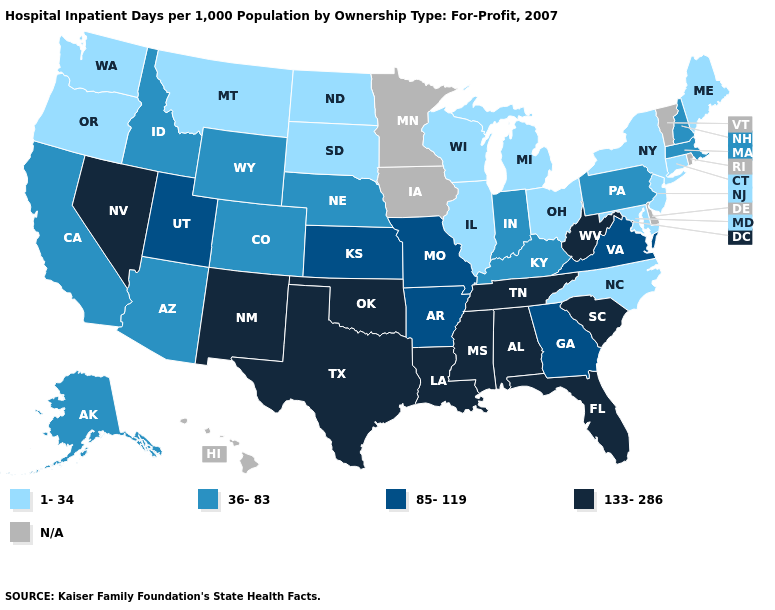Name the states that have a value in the range 36-83?
Answer briefly. Alaska, Arizona, California, Colorado, Idaho, Indiana, Kentucky, Massachusetts, Nebraska, New Hampshire, Pennsylvania, Wyoming. Which states have the highest value in the USA?
Concise answer only. Alabama, Florida, Louisiana, Mississippi, Nevada, New Mexico, Oklahoma, South Carolina, Tennessee, Texas, West Virginia. Does North Carolina have the lowest value in the South?
Be succinct. Yes. Name the states that have a value in the range 133-286?
Give a very brief answer. Alabama, Florida, Louisiana, Mississippi, Nevada, New Mexico, Oklahoma, South Carolina, Tennessee, Texas, West Virginia. What is the value of Oklahoma?
Short answer required. 133-286. What is the value of Kansas?
Keep it brief. 85-119. What is the value of New York?
Keep it brief. 1-34. Does Indiana have the highest value in the USA?
Concise answer only. No. What is the value of Alaska?
Keep it brief. 36-83. Does New York have the lowest value in the Northeast?
Keep it brief. Yes. Does the first symbol in the legend represent the smallest category?
Answer briefly. Yes. What is the value of North Dakota?
Give a very brief answer. 1-34. What is the value of Utah?
Short answer required. 85-119. Which states hav the highest value in the West?
Answer briefly. Nevada, New Mexico. 